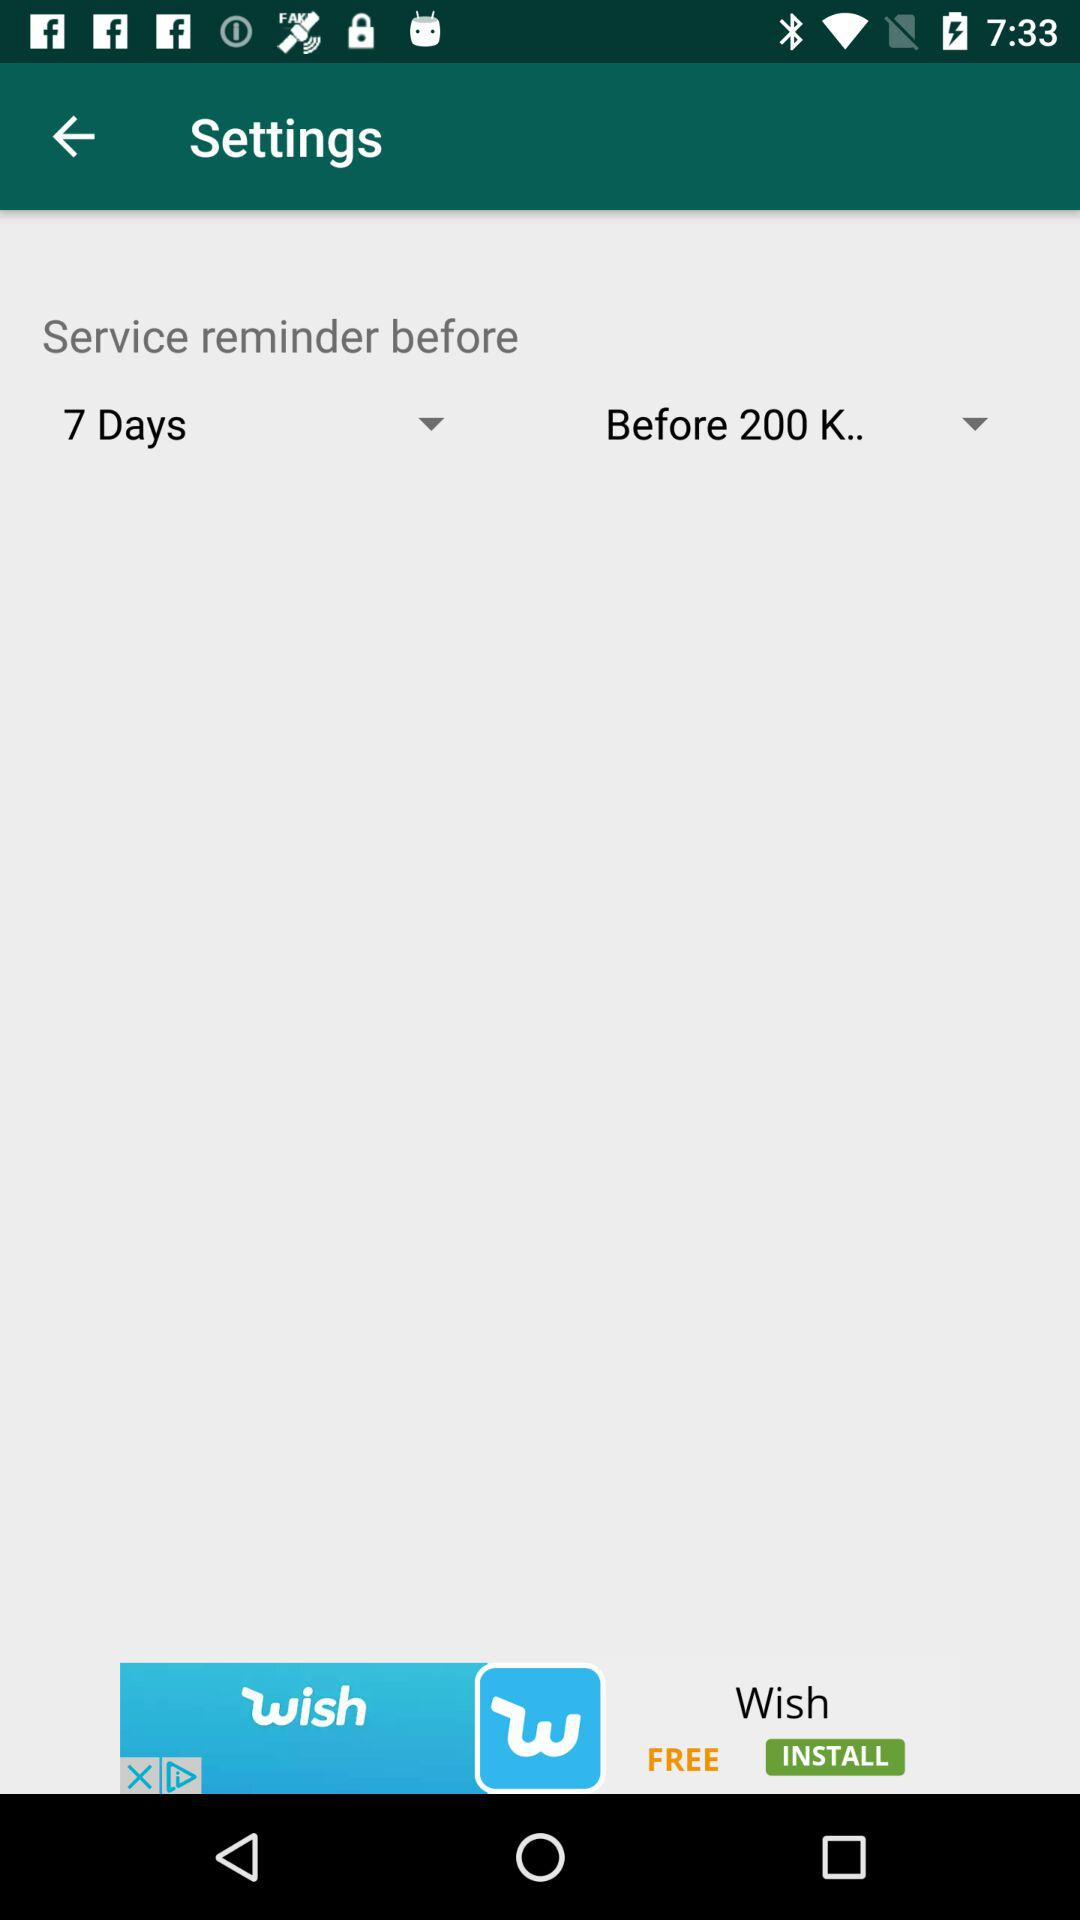How many days before it reminds us about the service? It will remind you about the service 7 days before. 